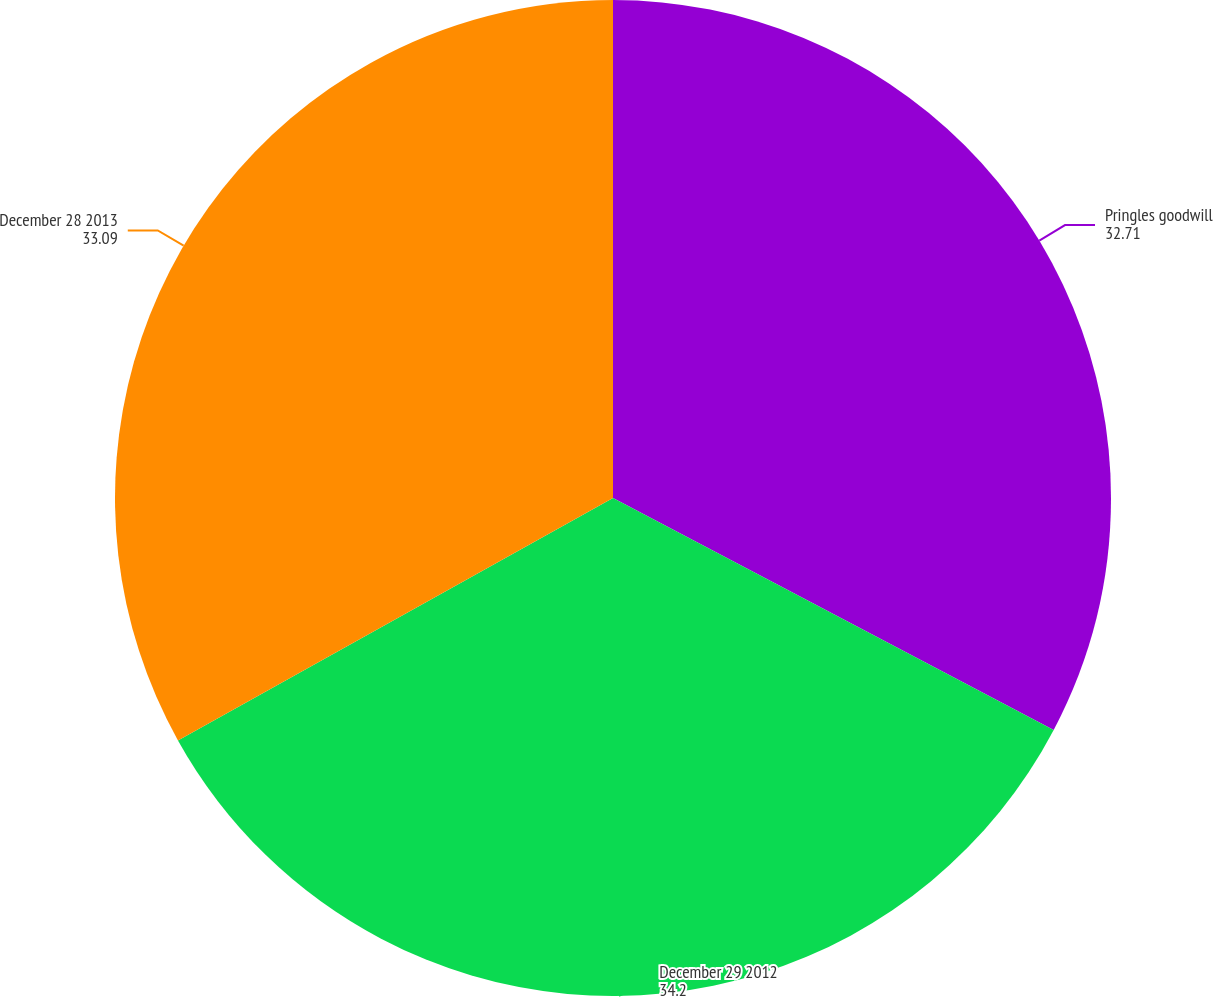Convert chart. <chart><loc_0><loc_0><loc_500><loc_500><pie_chart><fcel>Pringles goodwill<fcel>December 29 2012<fcel>December 28 2013<nl><fcel>32.71%<fcel>34.2%<fcel>33.09%<nl></chart> 